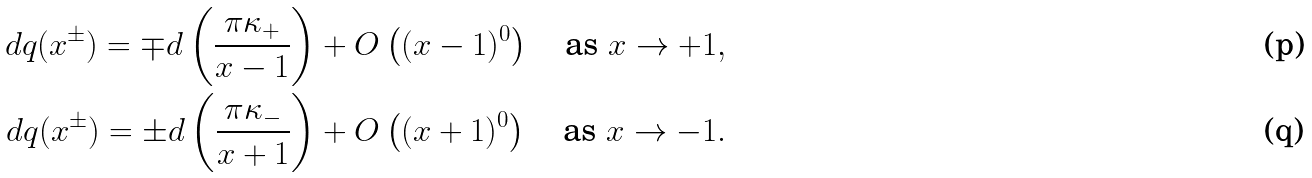<formula> <loc_0><loc_0><loc_500><loc_500>d q ( x ^ { \pm } ) = \mp d \left ( \frac { \pi \kappa _ { + } } { x - 1 } \right ) + O \left ( ( x - 1 ) ^ { 0 } \right ) \quad \text {as } x \rightarrow + 1 , \\ d q ( x ^ { \pm } ) = \pm d \left ( \frac { \pi \kappa _ { - } } { x + 1 } \right ) + O \left ( ( x + 1 ) ^ { 0 } \right ) \quad \text {as } x \rightarrow - 1 .</formula> 